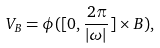Convert formula to latex. <formula><loc_0><loc_0><loc_500><loc_500>V _ { B } = \phi ( [ 0 , \frac { 2 \pi } { | \omega | } ] \times B ) ,</formula> 